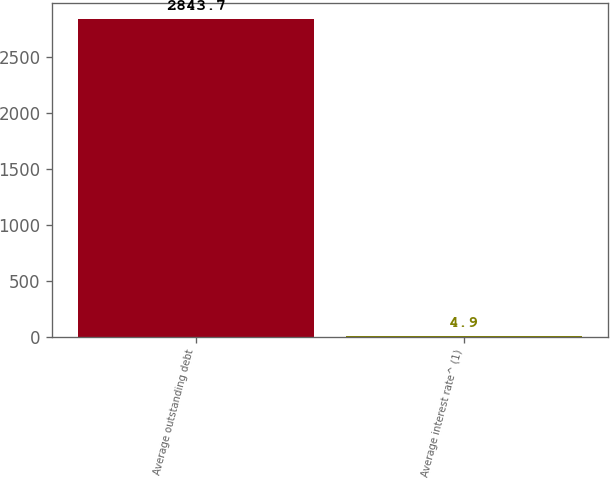Convert chart. <chart><loc_0><loc_0><loc_500><loc_500><bar_chart><fcel>Average outstanding debt<fcel>Average interest rate^ (1)<nl><fcel>2843.7<fcel>4.9<nl></chart> 